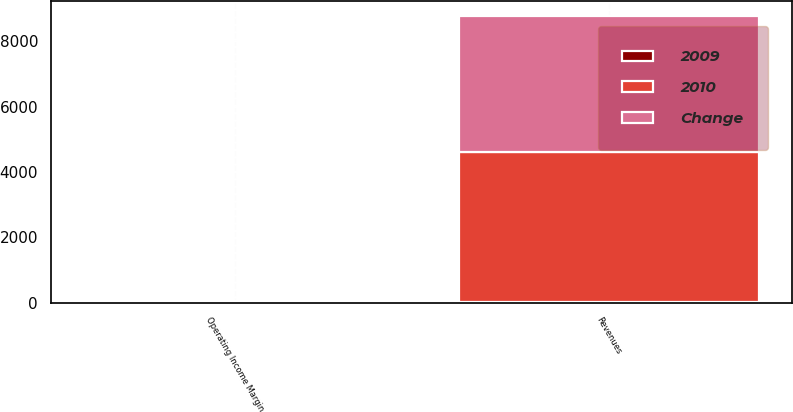Convert chart to OTSL. <chart><loc_0><loc_0><loc_500><loc_500><stacked_bar_chart><ecel><fcel>Revenues<fcel>Operating Income Margin<nl><fcel>2010<fcel>4611.8<fcel>21.3<nl><fcel>Change<fcel>4153.9<fcel>20.2<nl><fcel>2009<fcel>11<fcel>1.1<nl></chart> 